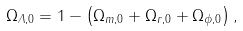<formula> <loc_0><loc_0><loc_500><loc_500>\Omega _ { { \mathit \Lambda } , 0 } = 1 - \left ( \Omega _ { m , 0 } + \Omega _ { r , 0 } + \Omega _ { \phi , 0 } \right ) ,</formula> 